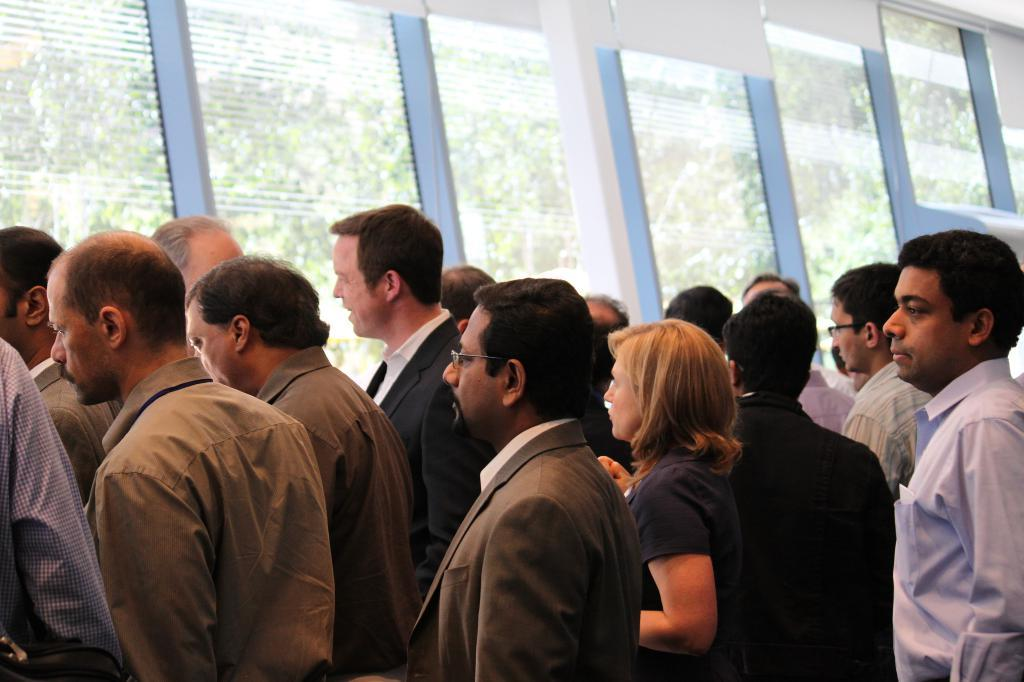What are the people in the image doing near the windows? The people in the image are standing near the windows. What can be seen outside the windows in the image? Trees and electric cables are visible outside the windows in the image. How many times does the sea appear in the image? The sea is not present in the image; only trees and electric cables are visible outside the windows. 